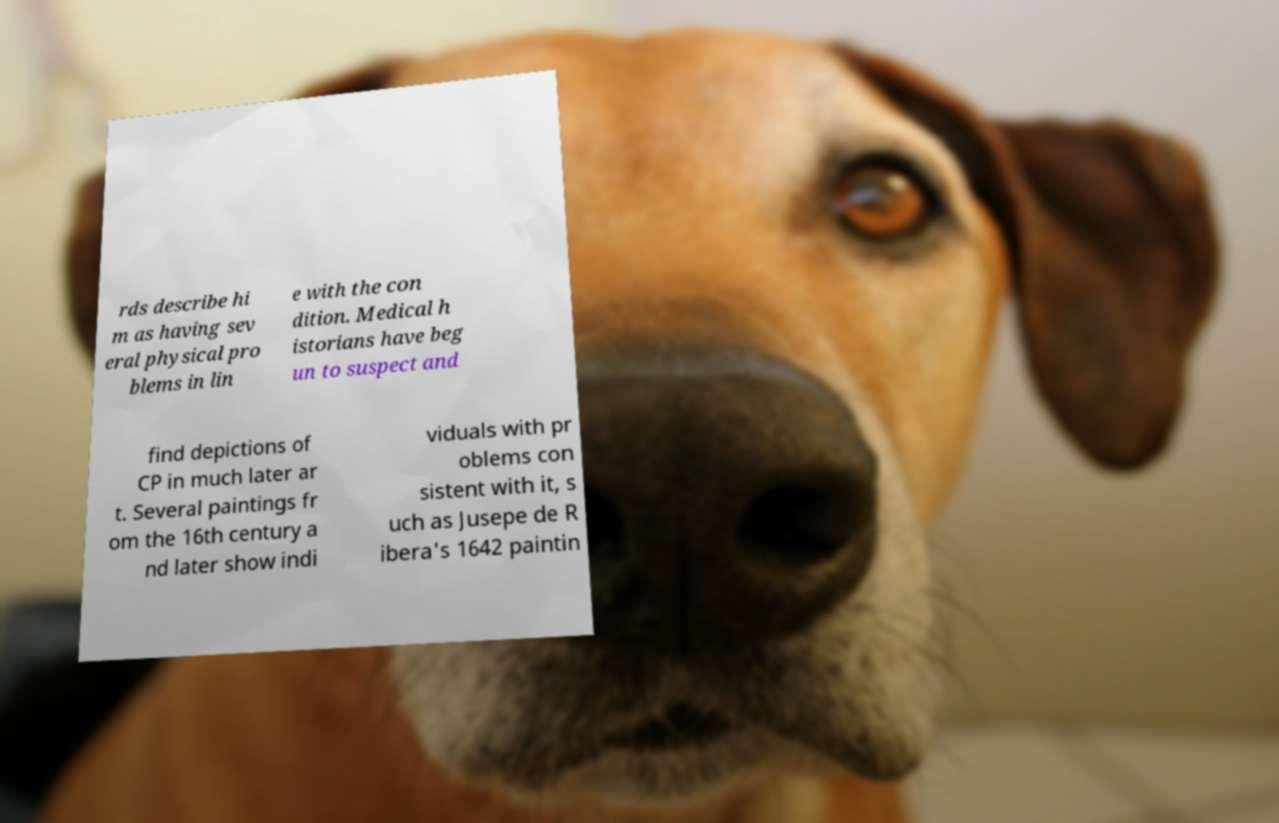Can you read and provide the text displayed in the image?This photo seems to have some interesting text. Can you extract and type it out for me? rds describe hi m as having sev eral physical pro blems in lin e with the con dition. Medical h istorians have beg un to suspect and find depictions of CP in much later ar t. Several paintings fr om the 16th century a nd later show indi viduals with pr oblems con sistent with it, s uch as Jusepe de R ibera's 1642 paintin 